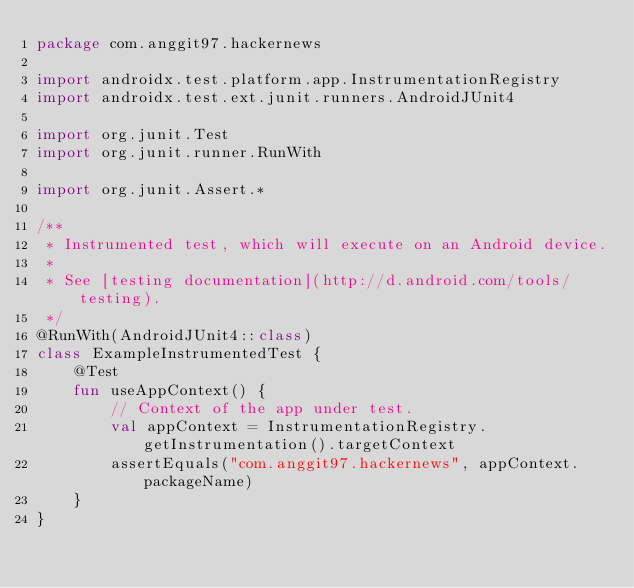Convert code to text. <code><loc_0><loc_0><loc_500><loc_500><_Kotlin_>package com.anggit97.hackernews

import androidx.test.platform.app.InstrumentationRegistry
import androidx.test.ext.junit.runners.AndroidJUnit4

import org.junit.Test
import org.junit.runner.RunWith

import org.junit.Assert.*

/**
 * Instrumented test, which will execute on an Android device.
 *
 * See [testing documentation](http://d.android.com/tools/testing).
 */
@RunWith(AndroidJUnit4::class)
class ExampleInstrumentedTest {
    @Test
    fun useAppContext() {
        // Context of the app under test.
        val appContext = InstrumentationRegistry.getInstrumentation().targetContext
        assertEquals("com.anggit97.hackernews", appContext.packageName)
    }
}
</code> 